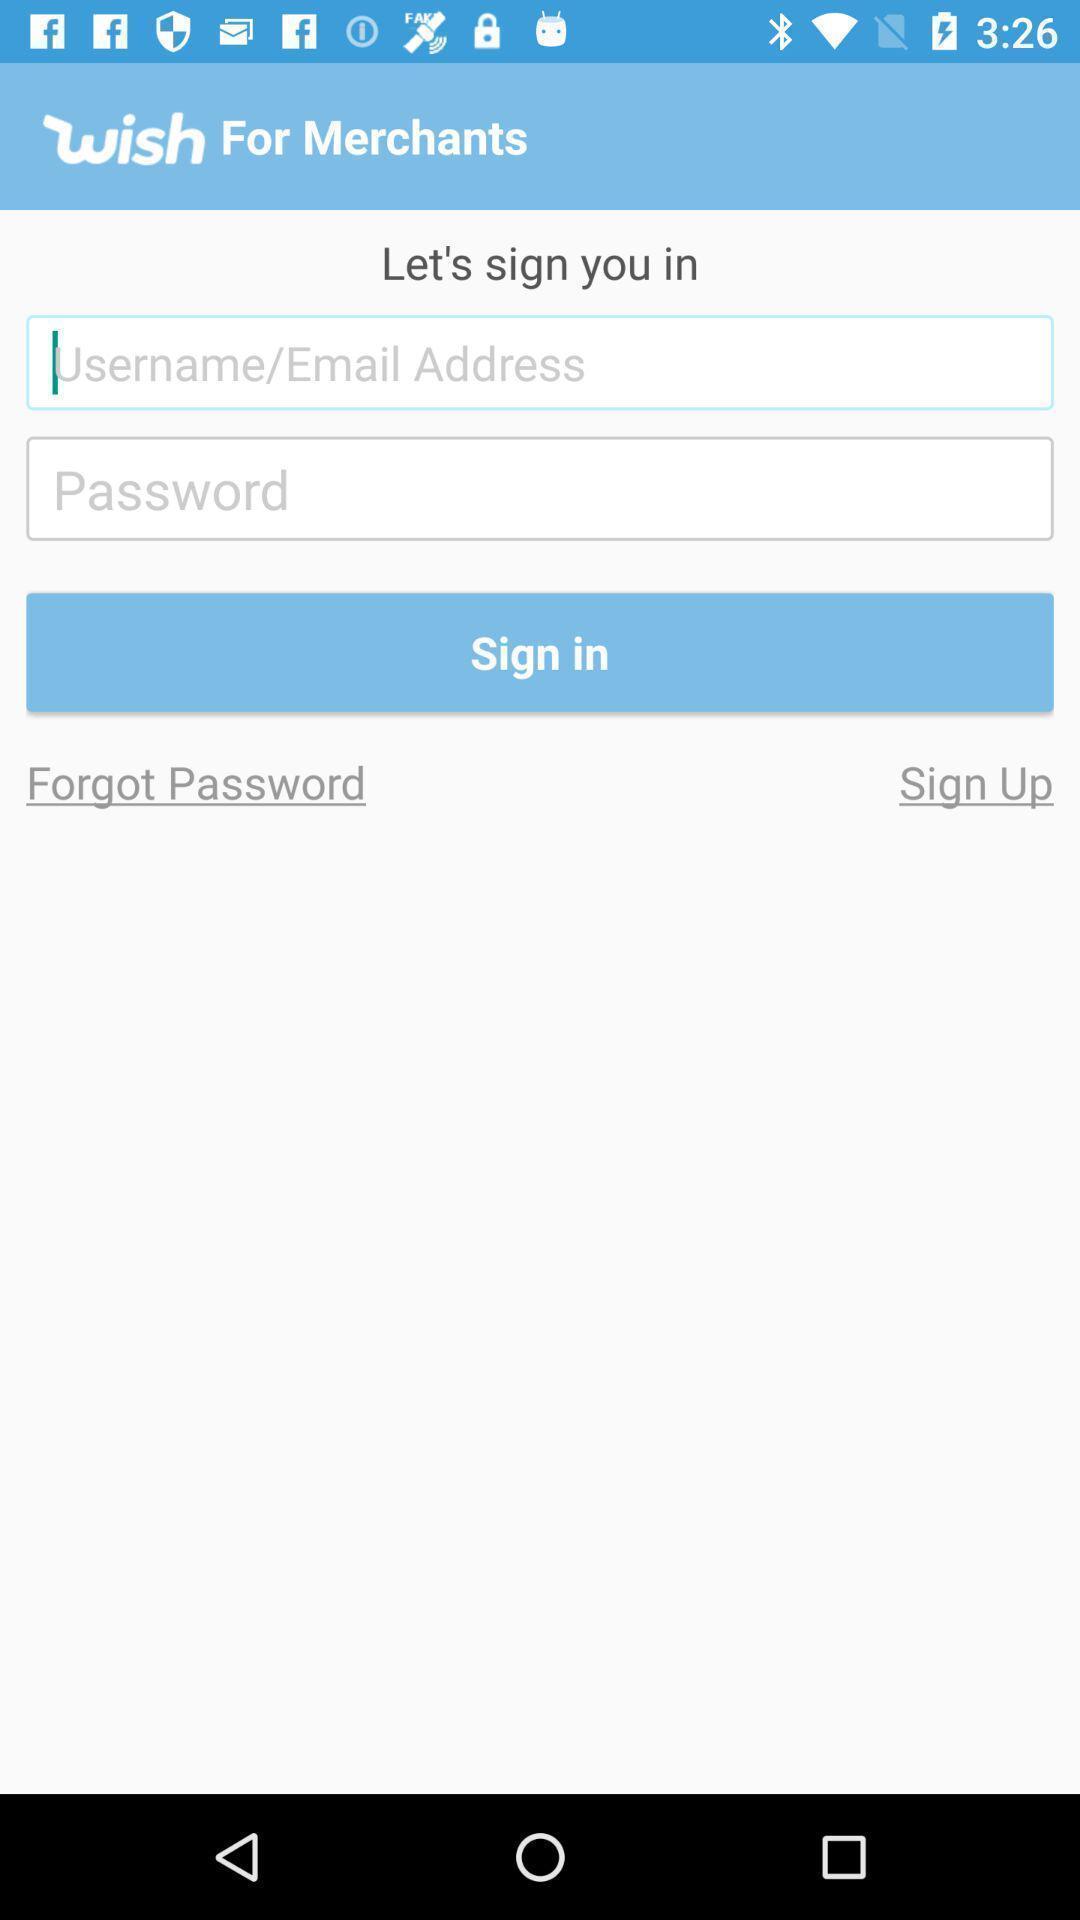Provide a textual representation of this image. Sign-in page. 